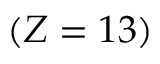<formula> <loc_0><loc_0><loc_500><loc_500>( Z = 1 3 )</formula> 